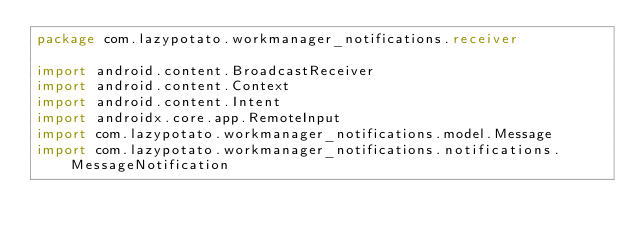Convert code to text. <code><loc_0><loc_0><loc_500><loc_500><_Kotlin_>package com.lazypotato.workmanager_notifications.receiver

import android.content.BroadcastReceiver
import android.content.Context
import android.content.Intent
import androidx.core.app.RemoteInput
import com.lazypotato.workmanager_notifications.model.Message
import com.lazypotato.workmanager_notifications.notifications.MessageNotification
</code> 